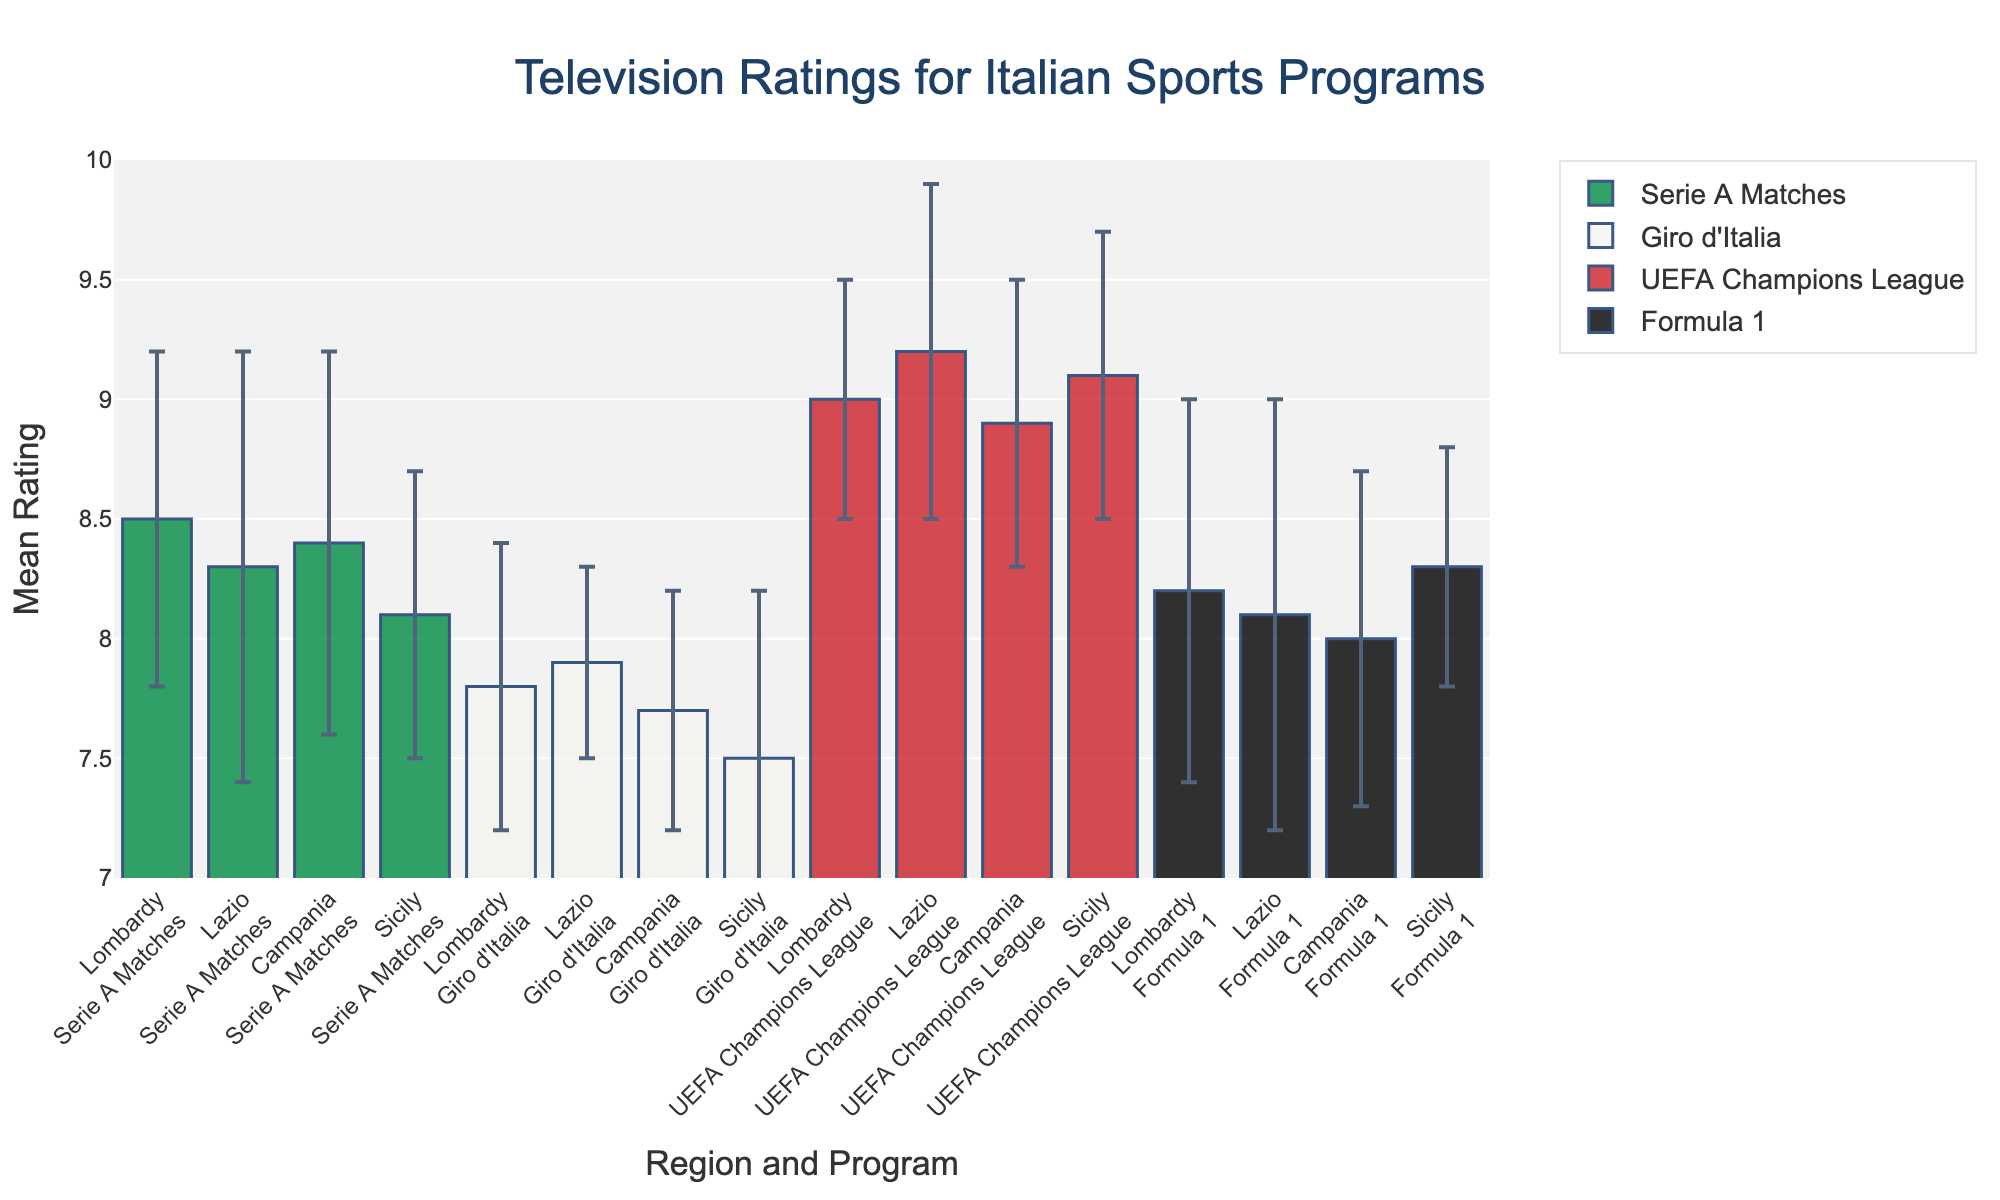What is the title of the plot? The title of the plot is usually displayed prominently at the top of the figure. Here, the title reads 'Television Ratings for Italian Sports Programs'.
Answer: Television Ratings for Italian Sports Programs Which region has the highest mean rating for UEFA Champions League? To find this, look at the bars for UEFA Champions League across all regions and compare their heights. The tallest bar for UEFA Champions League is in Lazio.
Answer: Lazio What is the mean rating for Formula 1 in Sicily and its standard deviation? Locate the bar associated with Formula 1 in Sicily. The mean rating for Formula 1 in Sicily is indicated at the top of the bar and the error bar represents the standard deviation. It shows a mean rating of 8.3 with a standard deviation of 0.5.
Answer: 8.3, 0.5 Which program has the highest variability in ratings in Campania? Variability is indicated by the length of the error bars. Look at the error bars for all programs in Campania and compare their lengths. Serie A Matches has the longest error bar, indicating the highest variability in ratings.
Answer: Serie A Matches How do the mean ratings of Serie A Matches compare between Lombardy and Lazio? To compare the mean ratings, look at the heights of the bars for Serie A Matches in both Lombardy and Lazio. In Lombardy, it is 8.5; in Lazio, it is 8.3. Lombardy has a higher mean rating for Serie A Matches than Lazio.
Answer: Lombardy > Lazio What is the mean rating difference between Giro d'Italia in Lombardy and Campania? Find the mean ratings for Giro d'Italia in Lombardy (7.8) and Campania (7.7), then subtract Campania's rating from Lombardy's. The difference is 7.8 - 7.7 = 0.1.
Answer: 0.1 Which region shows the least variability in ratings for the Giro d'Italia? Variability is shown by the length of the error bars. The shortest error bar for Giro d'Italia can be found by comparing all four regions (Lombardy, Lazio, Campania, Sicily). Lazio has the shortest error bar, indicating the least variability.
Answer: Lazio What is the average mean rating for Formula 1 across all regions? Calculate the mean ratings of Formula 1 across Lombardy (8.2), Lazio (8.1), Campania (8.0), and Sicily (8.3). Add these values and divide by the number of regions: (8.2 + 8.1 + 8.0 + 8.3) / 4 = 8.15.
Answer: 8.15 Which sports program has the lowest mean rating in Sicily? Look at the bars for each sports program in Sicily and compare their heights. The lowest bar represents the lowest mean rating, which belongs to Giro d'Italia with a mean rating of 7.5.
Answer: Giro d'Italia Which region has the most consistent ratings for sports programs overall? Consistency in ratings can be inferred by examining the lengths of the error bars across all programs in each region. The region with the shortest and most uniform error bars across all programs will be the most consistent. Lazio has relatively shorter and more uniform error bars, indicating the most consistency.
Answer: Lazio 